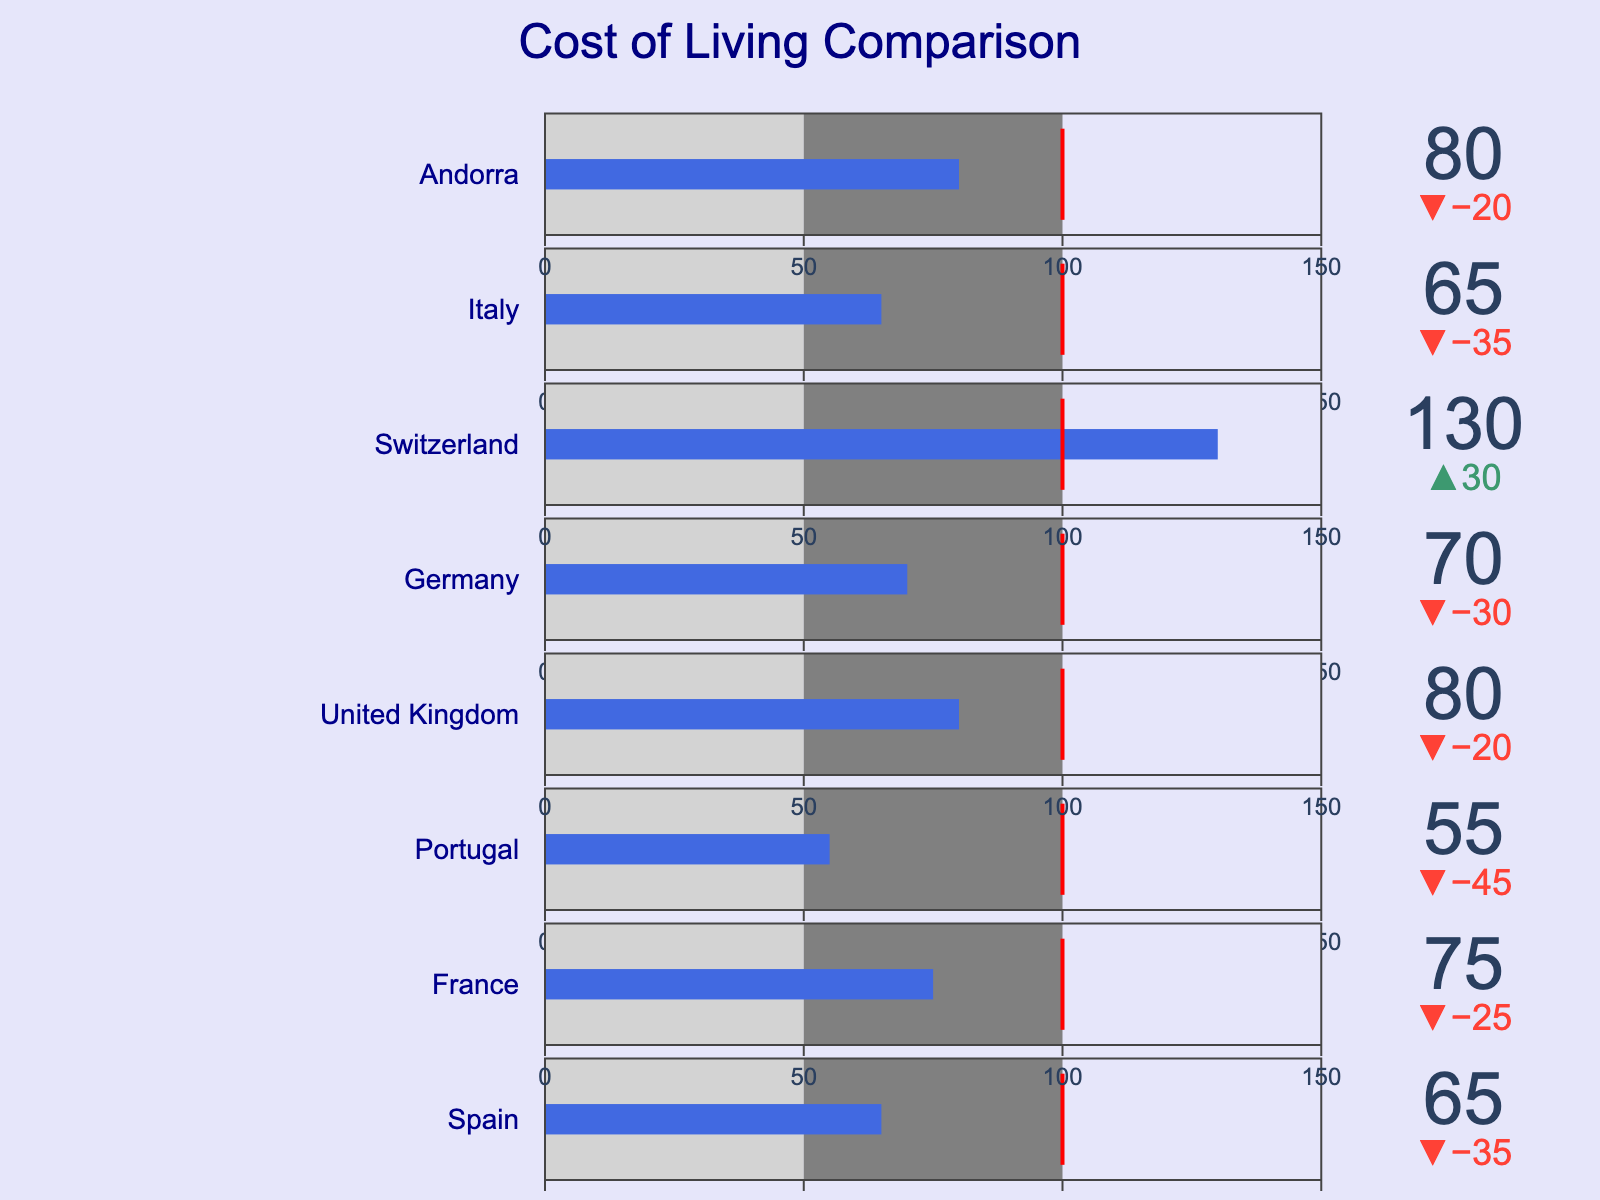What's the title of the figure? The title is shown at the top of the figure; it reads "Cost of Living Comparison".
Answer: Cost of Living Comparison How many countries are compared in the figure? There are eight bullet bars in the figure, each representing a country.
Answer: Eight Which country has the highest Cost of Living Index? The bullet bar for Switzerland extends the furthest to the right, indicating the highest Cost of Living Index.
Answer: Switzerland How does the Cost of Living Index for Andorra compare to its target value? The bullet bar for Andorra has a specified target of 100, while the actual value shown is 80.
Answer: Below the target What is the range of the Cost of Living Index used in the figure? Each bullet chart shows an axis ranging from 0 to 150, as indicated on the visual.
Answer: 0 to 150 Which countries have a Cost of Living Index above 70? The bars for United Kingdom, France, Germany, Andorra, and Switzerland all extend beyond the 70 mark on their bullet charts.
Answer: United Kingdom, France, Germany, Andorra, Switzerland What's the difference in the Cost of Living Index between Switzerland and Portugal? Switzerland has an index of 130, while Portugal has 55. Therefore, the difference is 130 - 55.
Answer: 75 Which countries have a Cost of Living Index equal to that of Andorra? The index for Andorra is 80. This same index is also shown for the United Kingdom.
Answer: United Kingdom How many countries have a Cost of Living Index lower than the target of 100? By observing the bars below the target mark, Spain, France, Portugal, Germany, Italy, and Andorra all have indices below 100.
Answer: Six countries Between Germany and Italy, which has a higher Cost of Living Index? The bullet bar for Germany extends further to the right compared to Italy, indicating a higher Cost of Living Index.
Answer: Germany 